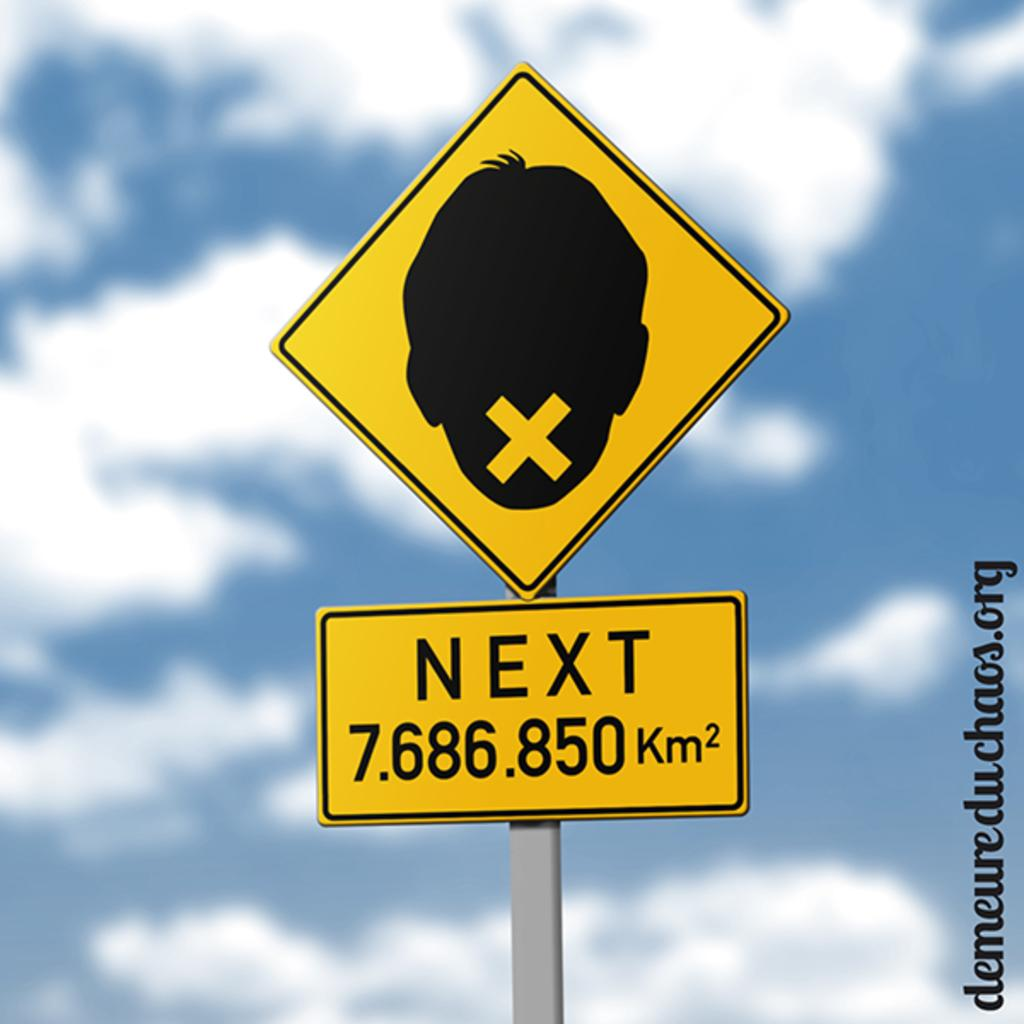<image>
Relay a brief, clear account of the picture shown. a sign with the word next on the front 